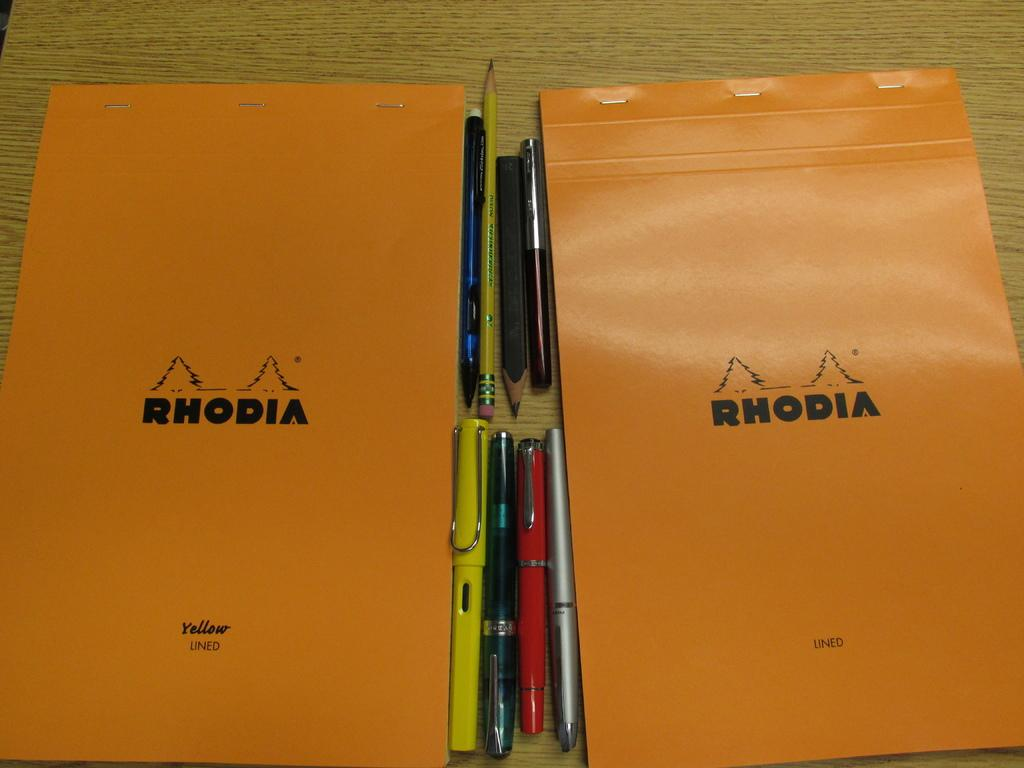What is located in the center of the image? There is a table in the center of the image. What items can be seen on the table? There are books, pens, and pencils on the table. What flavor of drum can be seen on the table in the image? There is no drum present in the image, and therefore no flavor can be determined. 